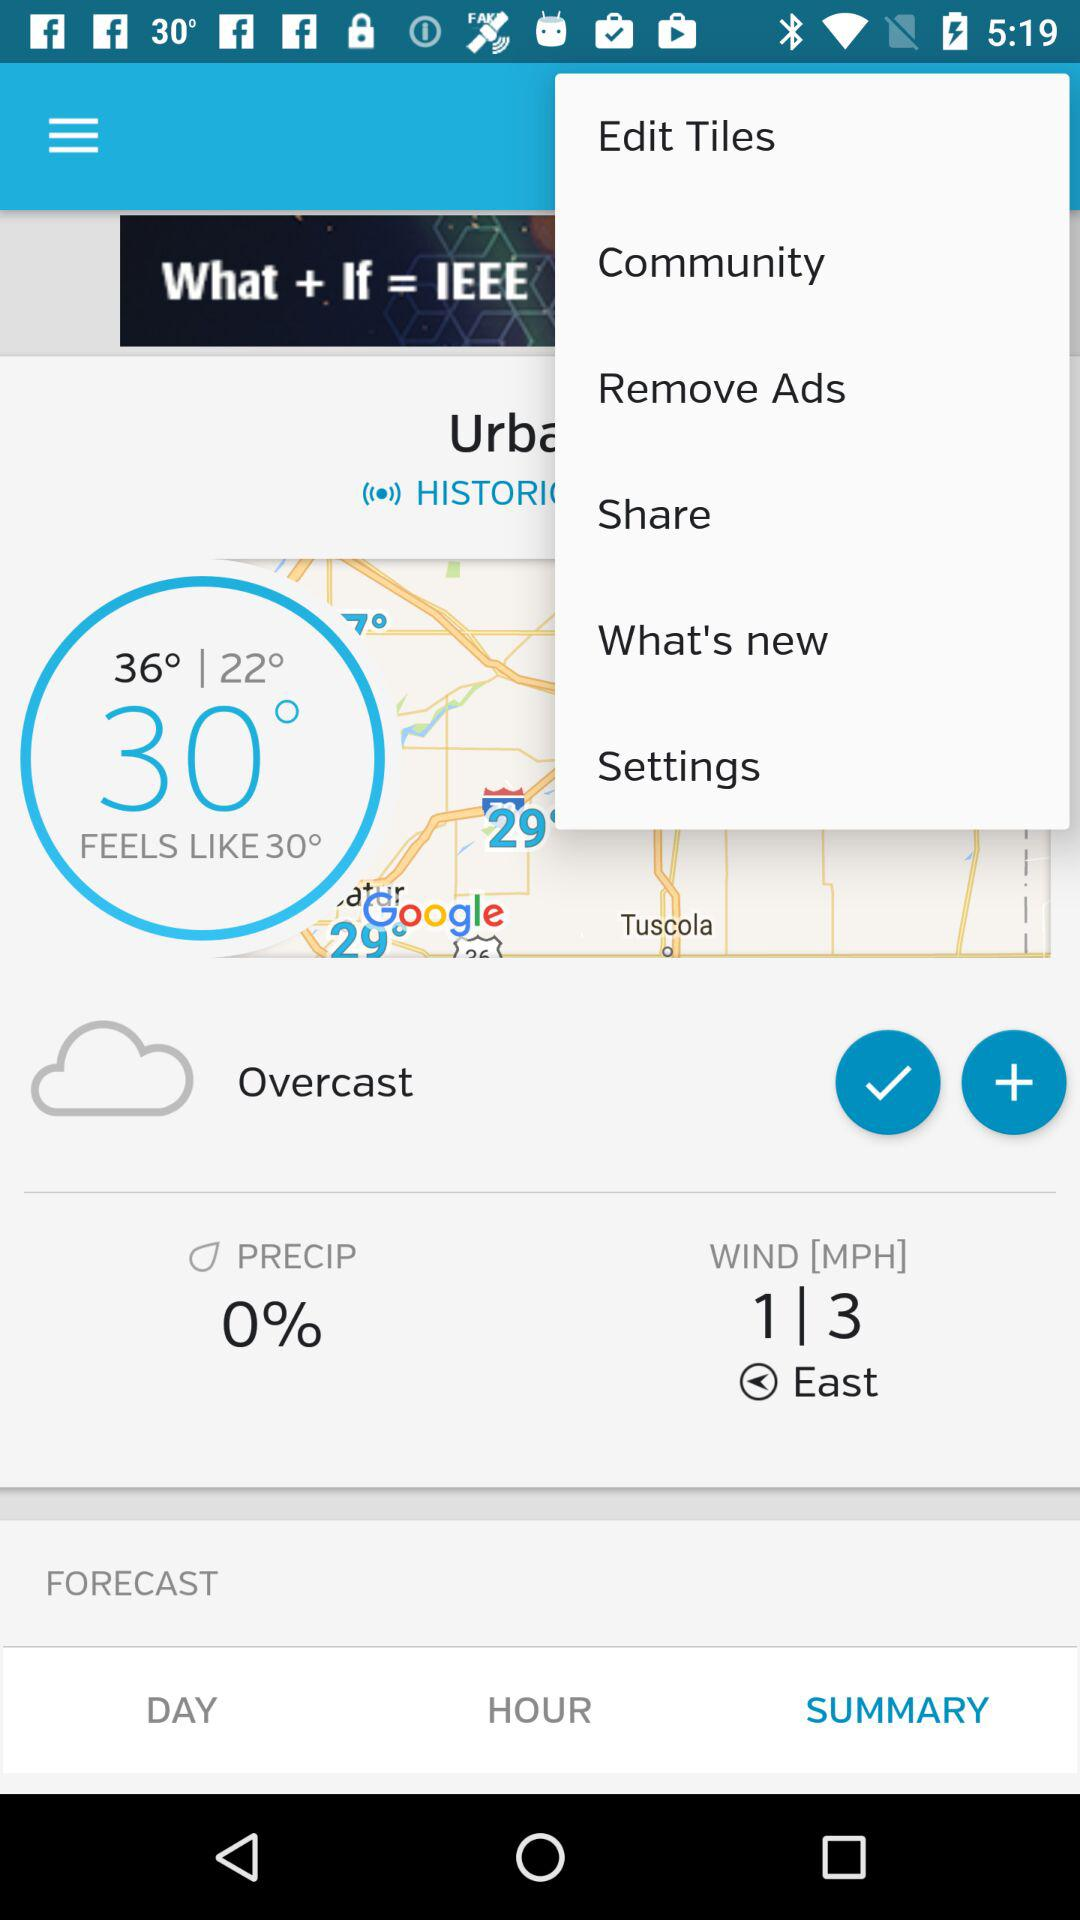What is the temperature? The temperature is 30°. 